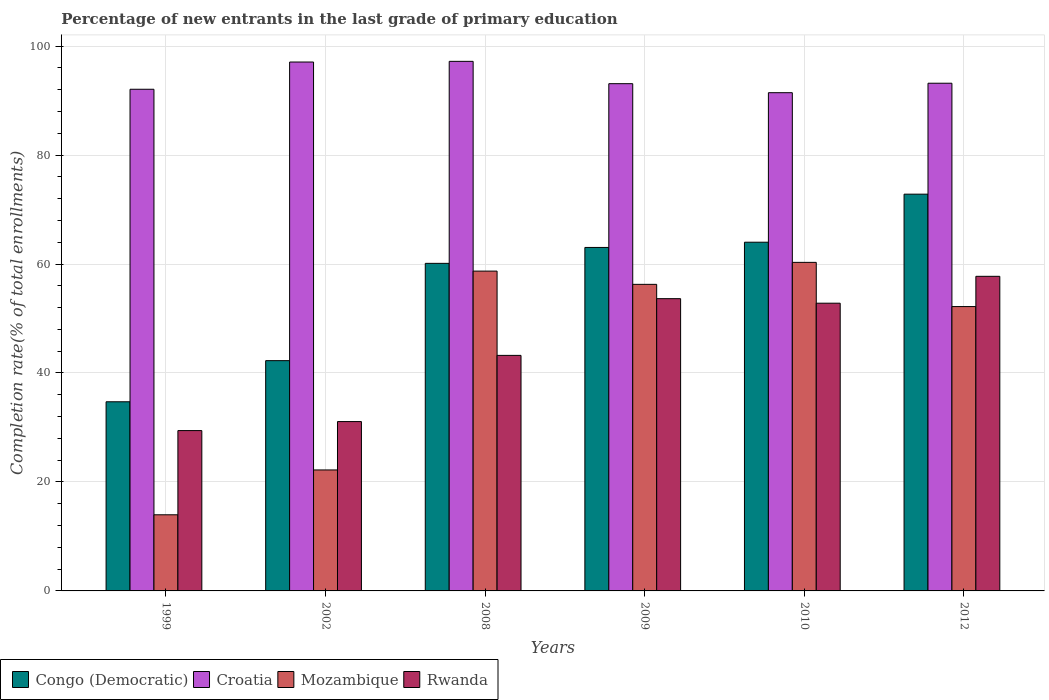How many groups of bars are there?
Offer a terse response. 6. Are the number of bars per tick equal to the number of legend labels?
Make the answer very short. Yes. How many bars are there on the 6th tick from the left?
Give a very brief answer. 4. How many bars are there on the 1st tick from the right?
Your answer should be very brief. 4. What is the percentage of new entrants in Rwanda in 2002?
Give a very brief answer. 31.08. Across all years, what is the maximum percentage of new entrants in Rwanda?
Your answer should be very brief. 57.74. Across all years, what is the minimum percentage of new entrants in Rwanda?
Your answer should be very brief. 29.43. What is the total percentage of new entrants in Mozambique in the graph?
Your answer should be very brief. 263.62. What is the difference between the percentage of new entrants in Congo (Democratic) in 1999 and that in 2002?
Give a very brief answer. -7.55. What is the difference between the percentage of new entrants in Mozambique in 2002 and the percentage of new entrants in Croatia in 1999?
Your answer should be very brief. -69.87. What is the average percentage of new entrants in Mozambique per year?
Provide a succinct answer. 43.94. In the year 2009, what is the difference between the percentage of new entrants in Mozambique and percentage of new entrants in Croatia?
Make the answer very short. -36.83. In how many years, is the percentage of new entrants in Rwanda greater than 28 %?
Your answer should be very brief. 6. What is the ratio of the percentage of new entrants in Rwanda in 1999 to that in 2002?
Your response must be concise. 0.95. Is the percentage of new entrants in Rwanda in 2009 less than that in 2010?
Give a very brief answer. No. Is the difference between the percentage of new entrants in Mozambique in 2009 and 2012 greater than the difference between the percentage of new entrants in Croatia in 2009 and 2012?
Make the answer very short. Yes. What is the difference between the highest and the second highest percentage of new entrants in Rwanda?
Provide a short and direct response. 4.1. What is the difference between the highest and the lowest percentage of new entrants in Rwanda?
Give a very brief answer. 28.31. Is the sum of the percentage of new entrants in Rwanda in 2002 and 2010 greater than the maximum percentage of new entrants in Mozambique across all years?
Offer a very short reply. Yes. What does the 1st bar from the left in 2008 represents?
Your answer should be very brief. Congo (Democratic). What does the 3rd bar from the right in 2008 represents?
Your answer should be compact. Croatia. How many bars are there?
Give a very brief answer. 24. Are all the bars in the graph horizontal?
Keep it short and to the point. No. What is the difference between two consecutive major ticks on the Y-axis?
Make the answer very short. 20. Are the values on the major ticks of Y-axis written in scientific E-notation?
Offer a terse response. No. What is the title of the graph?
Give a very brief answer. Percentage of new entrants in the last grade of primary education. What is the label or title of the X-axis?
Offer a very short reply. Years. What is the label or title of the Y-axis?
Your response must be concise. Completion rate(% of total enrollments). What is the Completion rate(% of total enrollments) of Congo (Democratic) in 1999?
Your answer should be compact. 34.71. What is the Completion rate(% of total enrollments) of Croatia in 1999?
Your answer should be compact. 92.07. What is the Completion rate(% of total enrollments) in Mozambique in 1999?
Give a very brief answer. 13.97. What is the Completion rate(% of total enrollments) of Rwanda in 1999?
Keep it short and to the point. 29.43. What is the Completion rate(% of total enrollments) in Congo (Democratic) in 2002?
Ensure brevity in your answer.  42.26. What is the Completion rate(% of total enrollments) of Croatia in 2002?
Offer a very short reply. 97.07. What is the Completion rate(% of total enrollments) of Mozambique in 2002?
Give a very brief answer. 22.2. What is the Completion rate(% of total enrollments) in Rwanda in 2002?
Your answer should be compact. 31.08. What is the Completion rate(% of total enrollments) in Congo (Democratic) in 2008?
Make the answer very short. 60.12. What is the Completion rate(% of total enrollments) of Croatia in 2008?
Provide a succinct answer. 97.19. What is the Completion rate(% of total enrollments) of Mozambique in 2008?
Make the answer very short. 58.7. What is the Completion rate(% of total enrollments) in Rwanda in 2008?
Ensure brevity in your answer.  43.23. What is the Completion rate(% of total enrollments) in Congo (Democratic) in 2009?
Keep it short and to the point. 63.04. What is the Completion rate(% of total enrollments) of Croatia in 2009?
Give a very brief answer. 93.09. What is the Completion rate(% of total enrollments) of Mozambique in 2009?
Provide a succinct answer. 56.26. What is the Completion rate(% of total enrollments) in Rwanda in 2009?
Your answer should be very brief. 53.64. What is the Completion rate(% of total enrollments) of Congo (Democratic) in 2010?
Offer a very short reply. 64. What is the Completion rate(% of total enrollments) in Croatia in 2010?
Your response must be concise. 91.44. What is the Completion rate(% of total enrollments) of Mozambique in 2010?
Give a very brief answer. 60.3. What is the Completion rate(% of total enrollments) of Rwanda in 2010?
Your answer should be very brief. 52.81. What is the Completion rate(% of total enrollments) in Congo (Democratic) in 2012?
Keep it short and to the point. 72.82. What is the Completion rate(% of total enrollments) of Croatia in 2012?
Provide a short and direct response. 93.18. What is the Completion rate(% of total enrollments) of Mozambique in 2012?
Make the answer very short. 52.19. What is the Completion rate(% of total enrollments) of Rwanda in 2012?
Provide a short and direct response. 57.74. Across all years, what is the maximum Completion rate(% of total enrollments) of Congo (Democratic)?
Provide a short and direct response. 72.82. Across all years, what is the maximum Completion rate(% of total enrollments) of Croatia?
Offer a terse response. 97.19. Across all years, what is the maximum Completion rate(% of total enrollments) in Mozambique?
Give a very brief answer. 60.3. Across all years, what is the maximum Completion rate(% of total enrollments) of Rwanda?
Provide a short and direct response. 57.74. Across all years, what is the minimum Completion rate(% of total enrollments) of Congo (Democratic)?
Ensure brevity in your answer.  34.71. Across all years, what is the minimum Completion rate(% of total enrollments) of Croatia?
Provide a succinct answer. 91.44. Across all years, what is the minimum Completion rate(% of total enrollments) in Mozambique?
Offer a terse response. 13.97. Across all years, what is the minimum Completion rate(% of total enrollments) in Rwanda?
Provide a short and direct response. 29.43. What is the total Completion rate(% of total enrollments) of Congo (Democratic) in the graph?
Make the answer very short. 336.95. What is the total Completion rate(% of total enrollments) in Croatia in the graph?
Your response must be concise. 564.04. What is the total Completion rate(% of total enrollments) in Mozambique in the graph?
Your answer should be very brief. 263.62. What is the total Completion rate(% of total enrollments) of Rwanda in the graph?
Your answer should be very brief. 267.92. What is the difference between the Completion rate(% of total enrollments) in Congo (Democratic) in 1999 and that in 2002?
Give a very brief answer. -7.55. What is the difference between the Completion rate(% of total enrollments) of Croatia in 1999 and that in 2002?
Offer a terse response. -5. What is the difference between the Completion rate(% of total enrollments) of Mozambique in 1999 and that in 2002?
Provide a succinct answer. -8.23. What is the difference between the Completion rate(% of total enrollments) in Rwanda in 1999 and that in 2002?
Your answer should be very brief. -1.66. What is the difference between the Completion rate(% of total enrollments) in Congo (Democratic) in 1999 and that in 2008?
Provide a short and direct response. -25.4. What is the difference between the Completion rate(% of total enrollments) of Croatia in 1999 and that in 2008?
Offer a terse response. -5.12. What is the difference between the Completion rate(% of total enrollments) of Mozambique in 1999 and that in 2008?
Your answer should be very brief. -44.72. What is the difference between the Completion rate(% of total enrollments) in Rwanda in 1999 and that in 2008?
Your answer should be very brief. -13.8. What is the difference between the Completion rate(% of total enrollments) in Congo (Democratic) in 1999 and that in 2009?
Your answer should be compact. -28.33. What is the difference between the Completion rate(% of total enrollments) in Croatia in 1999 and that in 2009?
Your answer should be very brief. -1.02. What is the difference between the Completion rate(% of total enrollments) in Mozambique in 1999 and that in 2009?
Your answer should be very brief. -42.29. What is the difference between the Completion rate(% of total enrollments) in Rwanda in 1999 and that in 2009?
Your answer should be very brief. -24.21. What is the difference between the Completion rate(% of total enrollments) of Congo (Democratic) in 1999 and that in 2010?
Your answer should be very brief. -29.28. What is the difference between the Completion rate(% of total enrollments) of Croatia in 1999 and that in 2010?
Offer a very short reply. 0.63. What is the difference between the Completion rate(% of total enrollments) of Mozambique in 1999 and that in 2010?
Make the answer very short. -46.33. What is the difference between the Completion rate(% of total enrollments) in Rwanda in 1999 and that in 2010?
Provide a short and direct response. -23.38. What is the difference between the Completion rate(% of total enrollments) in Congo (Democratic) in 1999 and that in 2012?
Provide a succinct answer. -38.1. What is the difference between the Completion rate(% of total enrollments) in Croatia in 1999 and that in 2012?
Ensure brevity in your answer.  -1.11. What is the difference between the Completion rate(% of total enrollments) of Mozambique in 1999 and that in 2012?
Your answer should be very brief. -38.21. What is the difference between the Completion rate(% of total enrollments) of Rwanda in 1999 and that in 2012?
Keep it short and to the point. -28.31. What is the difference between the Completion rate(% of total enrollments) in Congo (Democratic) in 2002 and that in 2008?
Provide a short and direct response. -17.86. What is the difference between the Completion rate(% of total enrollments) in Croatia in 2002 and that in 2008?
Your answer should be very brief. -0.12. What is the difference between the Completion rate(% of total enrollments) of Mozambique in 2002 and that in 2008?
Provide a short and direct response. -36.49. What is the difference between the Completion rate(% of total enrollments) of Rwanda in 2002 and that in 2008?
Offer a terse response. -12.15. What is the difference between the Completion rate(% of total enrollments) of Congo (Democratic) in 2002 and that in 2009?
Make the answer very short. -20.78. What is the difference between the Completion rate(% of total enrollments) of Croatia in 2002 and that in 2009?
Provide a short and direct response. 3.97. What is the difference between the Completion rate(% of total enrollments) in Mozambique in 2002 and that in 2009?
Give a very brief answer. -34.06. What is the difference between the Completion rate(% of total enrollments) of Rwanda in 2002 and that in 2009?
Your answer should be very brief. -22.56. What is the difference between the Completion rate(% of total enrollments) of Congo (Democratic) in 2002 and that in 2010?
Ensure brevity in your answer.  -21.74. What is the difference between the Completion rate(% of total enrollments) of Croatia in 2002 and that in 2010?
Provide a succinct answer. 5.63. What is the difference between the Completion rate(% of total enrollments) of Mozambique in 2002 and that in 2010?
Provide a short and direct response. -38.1. What is the difference between the Completion rate(% of total enrollments) of Rwanda in 2002 and that in 2010?
Your answer should be very brief. -21.72. What is the difference between the Completion rate(% of total enrollments) in Congo (Democratic) in 2002 and that in 2012?
Give a very brief answer. -30.56. What is the difference between the Completion rate(% of total enrollments) of Croatia in 2002 and that in 2012?
Your response must be concise. 3.89. What is the difference between the Completion rate(% of total enrollments) of Mozambique in 2002 and that in 2012?
Your response must be concise. -29.98. What is the difference between the Completion rate(% of total enrollments) of Rwanda in 2002 and that in 2012?
Keep it short and to the point. -26.66. What is the difference between the Completion rate(% of total enrollments) in Congo (Democratic) in 2008 and that in 2009?
Offer a terse response. -2.92. What is the difference between the Completion rate(% of total enrollments) of Croatia in 2008 and that in 2009?
Give a very brief answer. 4.1. What is the difference between the Completion rate(% of total enrollments) in Mozambique in 2008 and that in 2009?
Your answer should be compact. 2.43. What is the difference between the Completion rate(% of total enrollments) of Rwanda in 2008 and that in 2009?
Make the answer very short. -10.41. What is the difference between the Completion rate(% of total enrollments) in Congo (Democratic) in 2008 and that in 2010?
Provide a short and direct response. -3.88. What is the difference between the Completion rate(% of total enrollments) in Croatia in 2008 and that in 2010?
Your answer should be compact. 5.75. What is the difference between the Completion rate(% of total enrollments) in Mozambique in 2008 and that in 2010?
Offer a very short reply. -1.6. What is the difference between the Completion rate(% of total enrollments) of Rwanda in 2008 and that in 2010?
Offer a very short reply. -9.58. What is the difference between the Completion rate(% of total enrollments) in Congo (Democratic) in 2008 and that in 2012?
Keep it short and to the point. -12.7. What is the difference between the Completion rate(% of total enrollments) of Croatia in 2008 and that in 2012?
Your answer should be very brief. 4.01. What is the difference between the Completion rate(% of total enrollments) in Mozambique in 2008 and that in 2012?
Offer a terse response. 6.51. What is the difference between the Completion rate(% of total enrollments) in Rwanda in 2008 and that in 2012?
Provide a succinct answer. -14.51. What is the difference between the Completion rate(% of total enrollments) in Congo (Democratic) in 2009 and that in 2010?
Give a very brief answer. -0.96. What is the difference between the Completion rate(% of total enrollments) in Croatia in 2009 and that in 2010?
Make the answer very short. 1.65. What is the difference between the Completion rate(% of total enrollments) in Mozambique in 2009 and that in 2010?
Your answer should be compact. -4.04. What is the difference between the Completion rate(% of total enrollments) of Rwanda in 2009 and that in 2010?
Give a very brief answer. 0.83. What is the difference between the Completion rate(% of total enrollments) of Congo (Democratic) in 2009 and that in 2012?
Offer a very short reply. -9.78. What is the difference between the Completion rate(% of total enrollments) of Croatia in 2009 and that in 2012?
Your response must be concise. -0.08. What is the difference between the Completion rate(% of total enrollments) of Mozambique in 2009 and that in 2012?
Offer a very short reply. 4.08. What is the difference between the Completion rate(% of total enrollments) in Rwanda in 2009 and that in 2012?
Keep it short and to the point. -4.1. What is the difference between the Completion rate(% of total enrollments) of Congo (Democratic) in 2010 and that in 2012?
Give a very brief answer. -8.82. What is the difference between the Completion rate(% of total enrollments) of Croatia in 2010 and that in 2012?
Offer a terse response. -1.74. What is the difference between the Completion rate(% of total enrollments) in Mozambique in 2010 and that in 2012?
Ensure brevity in your answer.  8.11. What is the difference between the Completion rate(% of total enrollments) of Rwanda in 2010 and that in 2012?
Your answer should be compact. -4.93. What is the difference between the Completion rate(% of total enrollments) in Congo (Democratic) in 1999 and the Completion rate(% of total enrollments) in Croatia in 2002?
Provide a succinct answer. -62.35. What is the difference between the Completion rate(% of total enrollments) of Congo (Democratic) in 1999 and the Completion rate(% of total enrollments) of Mozambique in 2002?
Provide a short and direct response. 12.51. What is the difference between the Completion rate(% of total enrollments) in Congo (Democratic) in 1999 and the Completion rate(% of total enrollments) in Rwanda in 2002?
Your answer should be compact. 3.63. What is the difference between the Completion rate(% of total enrollments) of Croatia in 1999 and the Completion rate(% of total enrollments) of Mozambique in 2002?
Your answer should be compact. 69.87. What is the difference between the Completion rate(% of total enrollments) of Croatia in 1999 and the Completion rate(% of total enrollments) of Rwanda in 2002?
Your answer should be compact. 60.99. What is the difference between the Completion rate(% of total enrollments) in Mozambique in 1999 and the Completion rate(% of total enrollments) in Rwanda in 2002?
Your answer should be compact. -17.11. What is the difference between the Completion rate(% of total enrollments) in Congo (Democratic) in 1999 and the Completion rate(% of total enrollments) in Croatia in 2008?
Offer a very short reply. -62.48. What is the difference between the Completion rate(% of total enrollments) in Congo (Democratic) in 1999 and the Completion rate(% of total enrollments) in Mozambique in 2008?
Offer a very short reply. -23.98. What is the difference between the Completion rate(% of total enrollments) of Congo (Democratic) in 1999 and the Completion rate(% of total enrollments) of Rwanda in 2008?
Your response must be concise. -8.52. What is the difference between the Completion rate(% of total enrollments) of Croatia in 1999 and the Completion rate(% of total enrollments) of Mozambique in 2008?
Your answer should be compact. 33.38. What is the difference between the Completion rate(% of total enrollments) in Croatia in 1999 and the Completion rate(% of total enrollments) in Rwanda in 2008?
Keep it short and to the point. 48.84. What is the difference between the Completion rate(% of total enrollments) of Mozambique in 1999 and the Completion rate(% of total enrollments) of Rwanda in 2008?
Your response must be concise. -29.26. What is the difference between the Completion rate(% of total enrollments) in Congo (Democratic) in 1999 and the Completion rate(% of total enrollments) in Croatia in 2009?
Your answer should be compact. -58.38. What is the difference between the Completion rate(% of total enrollments) in Congo (Democratic) in 1999 and the Completion rate(% of total enrollments) in Mozambique in 2009?
Your answer should be compact. -21.55. What is the difference between the Completion rate(% of total enrollments) in Congo (Democratic) in 1999 and the Completion rate(% of total enrollments) in Rwanda in 2009?
Offer a terse response. -18.93. What is the difference between the Completion rate(% of total enrollments) of Croatia in 1999 and the Completion rate(% of total enrollments) of Mozambique in 2009?
Provide a succinct answer. 35.81. What is the difference between the Completion rate(% of total enrollments) in Croatia in 1999 and the Completion rate(% of total enrollments) in Rwanda in 2009?
Provide a short and direct response. 38.43. What is the difference between the Completion rate(% of total enrollments) of Mozambique in 1999 and the Completion rate(% of total enrollments) of Rwanda in 2009?
Your response must be concise. -39.67. What is the difference between the Completion rate(% of total enrollments) in Congo (Democratic) in 1999 and the Completion rate(% of total enrollments) in Croatia in 2010?
Provide a short and direct response. -56.73. What is the difference between the Completion rate(% of total enrollments) of Congo (Democratic) in 1999 and the Completion rate(% of total enrollments) of Mozambique in 2010?
Offer a terse response. -25.59. What is the difference between the Completion rate(% of total enrollments) of Congo (Democratic) in 1999 and the Completion rate(% of total enrollments) of Rwanda in 2010?
Make the answer very short. -18.09. What is the difference between the Completion rate(% of total enrollments) of Croatia in 1999 and the Completion rate(% of total enrollments) of Mozambique in 2010?
Keep it short and to the point. 31.77. What is the difference between the Completion rate(% of total enrollments) of Croatia in 1999 and the Completion rate(% of total enrollments) of Rwanda in 2010?
Make the answer very short. 39.26. What is the difference between the Completion rate(% of total enrollments) of Mozambique in 1999 and the Completion rate(% of total enrollments) of Rwanda in 2010?
Provide a short and direct response. -38.83. What is the difference between the Completion rate(% of total enrollments) of Congo (Democratic) in 1999 and the Completion rate(% of total enrollments) of Croatia in 2012?
Your answer should be compact. -58.46. What is the difference between the Completion rate(% of total enrollments) of Congo (Democratic) in 1999 and the Completion rate(% of total enrollments) of Mozambique in 2012?
Offer a very short reply. -17.47. What is the difference between the Completion rate(% of total enrollments) in Congo (Democratic) in 1999 and the Completion rate(% of total enrollments) in Rwanda in 2012?
Your answer should be very brief. -23.03. What is the difference between the Completion rate(% of total enrollments) of Croatia in 1999 and the Completion rate(% of total enrollments) of Mozambique in 2012?
Give a very brief answer. 39.89. What is the difference between the Completion rate(% of total enrollments) in Croatia in 1999 and the Completion rate(% of total enrollments) in Rwanda in 2012?
Provide a succinct answer. 34.33. What is the difference between the Completion rate(% of total enrollments) in Mozambique in 1999 and the Completion rate(% of total enrollments) in Rwanda in 2012?
Give a very brief answer. -43.77. What is the difference between the Completion rate(% of total enrollments) of Congo (Democratic) in 2002 and the Completion rate(% of total enrollments) of Croatia in 2008?
Your answer should be very brief. -54.93. What is the difference between the Completion rate(% of total enrollments) in Congo (Democratic) in 2002 and the Completion rate(% of total enrollments) in Mozambique in 2008?
Keep it short and to the point. -16.43. What is the difference between the Completion rate(% of total enrollments) of Congo (Democratic) in 2002 and the Completion rate(% of total enrollments) of Rwanda in 2008?
Your answer should be compact. -0.97. What is the difference between the Completion rate(% of total enrollments) in Croatia in 2002 and the Completion rate(% of total enrollments) in Mozambique in 2008?
Your response must be concise. 38.37. What is the difference between the Completion rate(% of total enrollments) of Croatia in 2002 and the Completion rate(% of total enrollments) of Rwanda in 2008?
Ensure brevity in your answer.  53.84. What is the difference between the Completion rate(% of total enrollments) of Mozambique in 2002 and the Completion rate(% of total enrollments) of Rwanda in 2008?
Keep it short and to the point. -21.02. What is the difference between the Completion rate(% of total enrollments) of Congo (Democratic) in 2002 and the Completion rate(% of total enrollments) of Croatia in 2009?
Offer a terse response. -50.83. What is the difference between the Completion rate(% of total enrollments) in Congo (Democratic) in 2002 and the Completion rate(% of total enrollments) in Mozambique in 2009?
Provide a short and direct response. -14. What is the difference between the Completion rate(% of total enrollments) of Congo (Democratic) in 2002 and the Completion rate(% of total enrollments) of Rwanda in 2009?
Give a very brief answer. -11.38. What is the difference between the Completion rate(% of total enrollments) in Croatia in 2002 and the Completion rate(% of total enrollments) in Mozambique in 2009?
Offer a terse response. 40.8. What is the difference between the Completion rate(% of total enrollments) of Croatia in 2002 and the Completion rate(% of total enrollments) of Rwanda in 2009?
Your answer should be very brief. 43.43. What is the difference between the Completion rate(% of total enrollments) of Mozambique in 2002 and the Completion rate(% of total enrollments) of Rwanda in 2009?
Your answer should be very brief. -31.43. What is the difference between the Completion rate(% of total enrollments) of Congo (Democratic) in 2002 and the Completion rate(% of total enrollments) of Croatia in 2010?
Make the answer very short. -49.18. What is the difference between the Completion rate(% of total enrollments) in Congo (Democratic) in 2002 and the Completion rate(% of total enrollments) in Mozambique in 2010?
Provide a succinct answer. -18.04. What is the difference between the Completion rate(% of total enrollments) of Congo (Democratic) in 2002 and the Completion rate(% of total enrollments) of Rwanda in 2010?
Keep it short and to the point. -10.55. What is the difference between the Completion rate(% of total enrollments) of Croatia in 2002 and the Completion rate(% of total enrollments) of Mozambique in 2010?
Offer a terse response. 36.77. What is the difference between the Completion rate(% of total enrollments) in Croatia in 2002 and the Completion rate(% of total enrollments) in Rwanda in 2010?
Make the answer very short. 44.26. What is the difference between the Completion rate(% of total enrollments) of Mozambique in 2002 and the Completion rate(% of total enrollments) of Rwanda in 2010?
Offer a very short reply. -30.6. What is the difference between the Completion rate(% of total enrollments) of Congo (Democratic) in 2002 and the Completion rate(% of total enrollments) of Croatia in 2012?
Your answer should be very brief. -50.92. What is the difference between the Completion rate(% of total enrollments) of Congo (Democratic) in 2002 and the Completion rate(% of total enrollments) of Mozambique in 2012?
Ensure brevity in your answer.  -9.92. What is the difference between the Completion rate(% of total enrollments) in Congo (Democratic) in 2002 and the Completion rate(% of total enrollments) in Rwanda in 2012?
Your answer should be very brief. -15.48. What is the difference between the Completion rate(% of total enrollments) of Croatia in 2002 and the Completion rate(% of total enrollments) of Mozambique in 2012?
Make the answer very short. 44.88. What is the difference between the Completion rate(% of total enrollments) in Croatia in 2002 and the Completion rate(% of total enrollments) in Rwanda in 2012?
Provide a short and direct response. 39.33. What is the difference between the Completion rate(% of total enrollments) in Mozambique in 2002 and the Completion rate(% of total enrollments) in Rwanda in 2012?
Provide a short and direct response. -35.54. What is the difference between the Completion rate(% of total enrollments) of Congo (Democratic) in 2008 and the Completion rate(% of total enrollments) of Croatia in 2009?
Provide a succinct answer. -32.98. What is the difference between the Completion rate(% of total enrollments) of Congo (Democratic) in 2008 and the Completion rate(% of total enrollments) of Mozambique in 2009?
Offer a terse response. 3.85. What is the difference between the Completion rate(% of total enrollments) in Congo (Democratic) in 2008 and the Completion rate(% of total enrollments) in Rwanda in 2009?
Offer a very short reply. 6.48. What is the difference between the Completion rate(% of total enrollments) of Croatia in 2008 and the Completion rate(% of total enrollments) of Mozambique in 2009?
Offer a very short reply. 40.93. What is the difference between the Completion rate(% of total enrollments) in Croatia in 2008 and the Completion rate(% of total enrollments) in Rwanda in 2009?
Make the answer very short. 43.55. What is the difference between the Completion rate(% of total enrollments) of Mozambique in 2008 and the Completion rate(% of total enrollments) of Rwanda in 2009?
Keep it short and to the point. 5.06. What is the difference between the Completion rate(% of total enrollments) of Congo (Democratic) in 2008 and the Completion rate(% of total enrollments) of Croatia in 2010?
Give a very brief answer. -31.32. What is the difference between the Completion rate(% of total enrollments) in Congo (Democratic) in 2008 and the Completion rate(% of total enrollments) in Mozambique in 2010?
Provide a succinct answer. -0.18. What is the difference between the Completion rate(% of total enrollments) of Congo (Democratic) in 2008 and the Completion rate(% of total enrollments) of Rwanda in 2010?
Your answer should be compact. 7.31. What is the difference between the Completion rate(% of total enrollments) of Croatia in 2008 and the Completion rate(% of total enrollments) of Mozambique in 2010?
Provide a succinct answer. 36.89. What is the difference between the Completion rate(% of total enrollments) of Croatia in 2008 and the Completion rate(% of total enrollments) of Rwanda in 2010?
Your answer should be compact. 44.38. What is the difference between the Completion rate(% of total enrollments) of Mozambique in 2008 and the Completion rate(% of total enrollments) of Rwanda in 2010?
Ensure brevity in your answer.  5.89. What is the difference between the Completion rate(% of total enrollments) of Congo (Democratic) in 2008 and the Completion rate(% of total enrollments) of Croatia in 2012?
Provide a short and direct response. -33.06. What is the difference between the Completion rate(% of total enrollments) of Congo (Democratic) in 2008 and the Completion rate(% of total enrollments) of Mozambique in 2012?
Keep it short and to the point. 7.93. What is the difference between the Completion rate(% of total enrollments) in Congo (Democratic) in 2008 and the Completion rate(% of total enrollments) in Rwanda in 2012?
Make the answer very short. 2.38. What is the difference between the Completion rate(% of total enrollments) in Croatia in 2008 and the Completion rate(% of total enrollments) in Mozambique in 2012?
Make the answer very short. 45.01. What is the difference between the Completion rate(% of total enrollments) in Croatia in 2008 and the Completion rate(% of total enrollments) in Rwanda in 2012?
Keep it short and to the point. 39.45. What is the difference between the Completion rate(% of total enrollments) in Mozambique in 2008 and the Completion rate(% of total enrollments) in Rwanda in 2012?
Provide a succinct answer. 0.96. What is the difference between the Completion rate(% of total enrollments) of Congo (Democratic) in 2009 and the Completion rate(% of total enrollments) of Croatia in 2010?
Offer a very short reply. -28.4. What is the difference between the Completion rate(% of total enrollments) of Congo (Democratic) in 2009 and the Completion rate(% of total enrollments) of Mozambique in 2010?
Make the answer very short. 2.74. What is the difference between the Completion rate(% of total enrollments) in Congo (Democratic) in 2009 and the Completion rate(% of total enrollments) in Rwanda in 2010?
Give a very brief answer. 10.23. What is the difference between the Completion rate(% of total enrollments) in Croatia in 2009 and the Completion rate(% of total enrollments) in Mozambique in 2010?
Offer a very short reply. 32.79. What is the difference between the Completion rate(% of total enrollments) in Croatia in 2009 and the Completion rate(% of total enrollments) in Rwanda in 2010?
Offer a very short reply. 40.29. What is the difference between the Completion rate(% of total enrollments) of Mozambique in 2009 and the Completion rate(% of total enrollments) of Rwanda in 2010?
Provide a short and direct response. 3.46. What is the difference between the Completion rate(% of total enrollments) of Congo (Democratic) in 2009 and the Completion rate(% of total enrollments) of Croatia in 2012?
Make the answer very short. -30.14. What is the difference between the Completion rate(% of total enrollments) of Congo (Democratic) in 2009 and the Completion rate(% of total enrollments) of Mozambique in 2012?
Offer a terse response. 10.85. What is the difference between the Completion rate(% of total enrollments) of Congo (Democratic) in 2009 and the Completion rate(% of total enrollments) of Rwanda in 2012?
Keep it short and to the point. 5.3. What is the difference between the Completion rate(% of total enrollments) in Croatia in 2009 and the Completion rate(% of total enrollments) in Mozambique in 2012?
Ensure brevity in your answer.  40.91. What is the difference between the Completion rate(% of total enrollments) in Croatia in 2009 and the Completion rate(% of total enrollments) in Rwanda in 2012?
Make the answer very short. 35.35. What is the difference between the Completion rate(% of total enrollments) of Mozambique in 2009 and the Completion rate(% of total enrollments) of Rwanda in 2012?
Your response must be concise. -1.48. What is the difference between the Completion rate(% of total enrollments) of Congo (Democratic) in 2010 and the Completion rate(% of total enrollments) of Croatia in 2012?
Ensure brevity in your answer.  -29.18. What is the difference between the Completion rate(% of total enrollments) of Congo (Democratic) in 2010 and the Completion rate(% of total enrollments) of Mozambique in 2012?
Ensure brevity in your answer.  11.81. What is the difference between the Completion rate(% of total enrollments) of Congo (Democratic) in 2010 and the Completion rate(% of total enrollments) of Rwanda in 2012?
Provide a short and direct response. 6.26. What is the difference between the Completion rate(% of total enrollments) of Croatia in 2010 and the Completion rate(% of total enrollments) of Mozambique in 2012?
Provide a succinct answer. 39.25. What is the difference between the Completion rate(% of total enrollments) in Croatia in 2010 and the Completion rate(% of total enrollments) in Rwanda in 2012?
Offer a very short reply. 33.7. What is the difference between the Completion rate(% of total enrollments) of Mozambique in 2010 and the Completion rate(% of total enrollments) of Rwanda in 2012?
Your answer should be very brief. 2.56. What is the average Completion rate(% of total enrollments) of Congo (Democratic) per year?
Keep it short and to the point. 56.16. What is the average Completion rate(% of total enrollments) in Croatia per year?
Offer a very short reply. 94.01. What is the average Completion rate(% of total enrollments) in Mozambique per year?
Provide a short and direct response. 43.94. What is the average Completion rate(% of total enrollments) in Rwanda per year?
Provide a short and direct response. 44.65. In the year 1999, what is the difference between the Completion rate(% of total enrollments) in Congo (Democratic) and Completion rate(% of total enrollments) in Croatia?
Keep it short and to the point. -57.36. In the year 1999, what is the difference between the Completion rate(% of total enrollments) of Congo (Democratic) and Completion rate(% of total enrollments) of Mozambique?
Your answer should be very brief. 20.74. In the year 1999, what is the difference between the Completion rate(% of total enrollments) of Congo (Democratic) and Completion rate(% of total enrollments) of Rwanda?
Give a very brief answer. 5.29. In the year 1999, what is the difference between the Completion rate(% of total enrollments) of Croatia and Completion rate(% of total enrollments) of Mozambique?
Your response must be concise. 78.1. In the year 1999, what is the difference between the Completion rate(% of total enrollments) of Croatia and Completion rate(% of total enrollments) of Rwanda?
Provide a succinct answer. 62.65. In the year 1999, what is the difference between the Completion rate(% of total enrollments) in Mozambique and Completion rate(% of total enrollments) in Rwanda?
Ensure brevity in your answer.  -15.45. In the year 2002, what is the difference between the Completion rate(% of total enrollments) in Congo (Democratic) and Completion rate(% of total enrollments) in Croatia?
Offer a terse response. -54.81. In the year 2002, what is the difference between the Completion rate(% of total enrollments) in Congo (Democratic) and Completion rate(% of total enrollments) in Mozambique?
Offer a very short reply. 20.06. In the year 2002, what is the difference between the Completion rate(% of total enrollments) of Congo (Democratic) and Completion rate(% of total enrollments) of Rwanda?
Your answer should be compact. 11.18. In the year 2002, what is the difference between the Completion rate(% of total enrollments) in Croatia and Completion rate(% of total enrollments) in Mozambique?
Provide a succinct answer. 74.86. In the year 2002, what is the difference between the Completion rate(% of total enrollments) of Croatia and Completion rate(% of total enrollments) of Rwanda?
Provide a succinct answer. 65.99. In the year 2002, what is the difference between the Completion rate(% of total enrollments) in Mozambique and Completion rate(% of total enrollments) in Rwanda?
Your answer should be very brief. -8.88. In the year 2008, what is the difference between the Completion rate(% of total enrollments) of Congo (Democratic) and Completion rate(% of total enrollments) of Croatia?
Your answer should be very brief. -37.07. In the year 2008, what is the difference between the Completion rate(% of total enrollments) in Congo (Democratic) and Completion rate(% of total enrollments) in Mozambique?
Offer a very short reply. 1.42. In the year 2008, what is the difference between the Completion rate(% of total enrollments) of Congo (Democratic) and Completion rate(% of total enrollments) of Rwanda?
Your answer should be compact. 16.89. In the year 2008, what is the difference between the Completion rate(% of total enrollments) of Croatia and Completion rate(% of total enrollments) of Mozambique?
Keep it short and to the point. 38.5. In the year 2008, what is the difference between the Completion rate(% of total enrollments) of Croatia and Completion rate(% of total enrollments) of Rwanda?
Make the answer very short. 53.96. In the year 2008, what is the difference between the Completion rate(% of total enrollments) in Mozambique and Completion rate(% of total enrollments) in Rwanda?
Make the answer very short. 15.47. In the year 2009, what is the difference between the Completion rate(% of total enrollments) in Congo (Democratic) and Completion rate(% of total enrollments) in Croatia?
Ensure brevity in your answer.  -30.05. In the year 2009, what is the difference between the Completion rate(% of total enrollments) in Congo (Democratic) and Completion rate(% of total enrollments) in Mozambique?
Your response must be concise. 6.78. In the year 2009, what is the difference between the Completion rate(% of total enrollments) in Congo (Democratic) and Completion rate(% of total enrollments) in Rwanda?
Keep it short and to the point. 9.4. In the year 2009, what is the difference between the Completion rate(% of total enrollments) in Croatia and Completion rate(% of total enrollments) in Mozambique?
Offer a very short reply. 36.83. In the year 2009, what is the difference between the Completion rate(% of total enrollments) of Croatia and Completion rate(% of total enrollments) of Rwanda?
Offer a terse response. 39.45. In the year 2009, what is the difference between the Completion rate(% of total enrollments) of Mozambique and Completion rate(% of total enrollments) of Rwanda?
Ensure brevity in your answer.  2.62. In the year 2010, what is the difference between the Completion rate(% of total enrollments) in Congo (Democratic) and Completion rate(% of total enrollments) in Croatia?
Your response must be concise. -27.44. In the year 2010, what is the difference between the Completion rate(% of total enrollments) of Congo (Democratic) and Completion rate(% of total enrollments) of Mozambique?
Ensure brevity in your answer.  3.7. In the year 2010, what is the difference between the Completion rate(% of total enrollments) in Congo (Democratic) and Completion rate(% of total enrollments) in Rwanda?
Your answer should be very brief. 11.19. In the year 2010, what is the difference between the Completion rate(% of total enrollments) of Croatia and Completion rate(% of total enrollments) of Mozambique?
Offer a very short reply. 31.14. In the year 2010, what is the difference between the Completion rate(% of total enrollments) of Croatia and Completion rate(% of total enrollments) of Rwanda?
Your response must be concise. 38.63. In the year 2010, what is the difference between the Completion rate(% of total enrollments) in Mozambique and Completion rate(% of total enrollments) in Rwanda?
Your response must be concise. 7.49. In the year 2012, what is the difference between the Completion rate(% of total enrollments) of Congo (Democratic) and Completion rate(% of total enrollments) of Croatia?
Your answer should be compact. -20.36. In the year 2012, what is the difference between the Completion rate(% of total enrollments) of Congo (Democratic) and Completion rate(% of total enrollments) of Mozambique?
Your response must be concise. 20.63. In the year 2012, what is the difference between the Completion rate(% of total enrollments) of Congo (Democratic) and Completion rate(% of total enrollments) of Rwanda?
Ensure brevity in your answer.  15.08. In the year 2012, what is the difference between the Completion rate(% of total enrollments) in Croatia and Completion rate(% of total enrollments) in Mozambique?
Give a very brief answer. 40.99. In the year 2012, what is the difference between the Completion rate(% of total enrollments) of Croatia and Completion rate(% of total enrollments) of Rwanda?
Provide a succinct answer. 35.44. In the year 2012, what is the difference between the Completion rate(% of total enrollments) in Mozambique and Completion rate(% of total enrollments) in Rwanda?
Offer a very short reply. -5.55. What is the ratio of the Completion rate(% of total enrollments) in Congo (Democratic) in 1999 to that in 2002?
Offer a terse response. 0.82. What is the ratio of the Completion rate(% of total enrollments) of Croatia in 1999 to that in 2002?
Make the answer very short. 0.95. What is the ratio of the Completion rate(% of total enrollments) of Mozambique in 1999 to that in 2002?
Ensure brevity in your answer.  0.63. What is the ratio of the Completion rate(% of total enrollments) of Rwanda in 1999 to that in 2002?
Your response must be concise. 0.95. What is the ratio of the Completion rate(% of total enrollments) in Congo (Democratic) in 1999 to that in 2008?
Ensure brevity in your answer.  0.58. What is the ratio of the Completion rate(% of total enrollments) in Croatia in 1999 to that in 2008?
Your answer should be very brief. 0.95. What is the ratio of the Completion rate(% of total enrollments) of Mozambique in 1999 to that in 2008?
Ensure brevity in your answer.  0.24. What is the ratio of the Completion rate(% of total enrollments) of Rwanda in 1999 to that in 2008?
Ensure brevity in your answer.  0.68. What is the ratio of the Completion rate(% of total enrollments) in Congo (Democratic) in 1999 to that in 2009?
Offer a very short reply. 0.55. What is the ratio of the Completion rate(% of total enrollments) of Croatia in 1999 to that in 2009?
Offer a very short reply. 0.99. What is the ratio of the Completion rate(% of total enrollments) in Mozambique in 1999 to that in 2009?
Offer a terse response. 0.25. What is the ratio of the Completion rate(% of total enrollments) in Rwanda in 1999 to that in 2009?
Your answer should be compact. 0.55. What is the ratio of the Completion rate(% of total enrollments) of Congo (Democratic) in 1999 to that in 2010?
Make the answer very short. 0.54. What is the ratio of the Completion rate(% of total enrollments) of Croatia in 1999 to that in 2010?
Your response must be concise. 1.01. What is the ratio of the Completion rate(% of total enrollments) of Mozambique in 1999 to that in 2010?
Keep it short and to the point. 0.23. What is the ratio of the Completion rate(% of total enrollments) in Rwanda in 1999 to that in 2010?
Your answer should be very brief. 0.56. What is the ratio of the Completion rate(% of total enrollments) in Congo (Democratic) in 1999 to that in 2012?
Ensure brevity in your answer.  0.48. What is the ratio of the Completion rate(% of total enrollments) in Mozambique in 1999 to that in 2012?
Your answer should be very brief. 0.27. What is the ratio of the Completion rate(% of total enrollments) of Rwanda in 1999 to that in 2012?
Provide a succinct answer. 0.51. What is the ratio of the Completion rate(% of total enrollments) of Congo (Democratic) in 2002 to that in 2008?
Offer a terse response. 0.7. What is the ratio of the Completion rate(% of total enrollments) in Mozambique in 2002 to that in 2008?
Give a very brief answer. 0.38. What is the ratio of the Completion rate(% of total enrollments) of Rwanda in 2002 to that in 2008?
Your response must be concise. 0.72. What is the ratio of the Completion rate(% of total enrollments) in Congo (Democratic) in 2002 to that in 2009?
Your answer should be very brief. 0.67. What is the ratio of the Completion rate(% of total enrollments) of Croatia in 2002 to that in 2009?
Make the answer very short. 1.04. What is the ratio of the Completion rate(% of total enrollments) of Mozambique in 2002 to that in 2009?
Offer a terse response. 0.39. What is the ratio of the Completion rate(% of total enrollments) of Rwanda in 2002 to that in 2009?
Make the answer very short. 0.58. What is the ratio of the Completion rate(% of total enrollments) of Congo (Democratic) in 2002 to that in 2010?
Keep it short and to the point. 0.66. What is the ratio of the Completion rate(% of total enrollments) in Croatia in 2002 to that in 2010?
Keep it short and to the point. 1.06. What is the ratio of the Completion rate(% of total enrollments) in Mozambique in 2002 to that in 2010?
Make the answer very short. 0.37. What is the ratio of the Completion rate(% of total enrollments) of Rwanda in 2002 to that in 2010?
Provide a succinct answer. 0.59. What is the ratio of the Completion rate(% of total enrollments) in Congo (Democratic) in 2002 to that in 2012?
Provide a succinct answer. 0.58. What is the ratio of the Completion rate(% of total enrollments) of Croatia in 2002 to that in 2012?
Make the answer very short. 1.04. What is the ratio of the Completion rate(% of total enrollments) of Mozambique in 2002 to that in 2012?
Give a very brief answer. 0.43. What is the ratio of the Completion rate(% of total enrollments) in Rwanda in 2002 to that in 2012?
Give a very brief answer. 0.54. What is the ratio of the Completion rate(% of total enrollments) of Congo (Democratic) in 2008 to that in 2009?
Ensure brevity in your answer.  0.95. What is the ratio of the Completion rate(% of total enrollments) of Croatia in 2008 to that in 2009?
Keep it short and to the point. 1.04. What is the ratio of the Completion rate(% of total enrollments) in Mozambique in 2008 to that in 2009?
Your response must be concise. 1.04. What is the ratio of the Completion rate(% of total enrollments) in Rwanda in 2008 to that in 2009?
Give a very brief answer. 0.81. What is the ratio of the Completion rate(% of total enrollments) of Congo (Democratic) in 2008 to that in 2010?
Offer a very short reply. 0.94. What is the ratio of the Completion rate(% of total enrollments) of Croatia in 2008 to that in 2010?
Your answer should be very brief. 1.06. What is the ratio of the Completion rate(% of total enrollments) of Mozambique in 2008 to that in 2010?
Your answer should be very brief. 0.97. What is the ratio of the Completion rate(% of total enrollments) of Rwanda in 2008 to that in 2010?
Your answer should be compact. 0.82. What is the ratio of the Completion rate(% of total enrollments) of Congo (Democratic) in 2008 to that in 2012?
Provide a succinct answer. 0.83. What is the ratio of the Completion rate(% of total enrollments) of Croatia in 2008 to that in 2012?
Offer a very short reply. 1.04. What is the ratio of the Completion rate(% of total enrollments) of Mozambique in 2008 to that in 2012?
Your answer should be compact. 1.12. What is the ratio of the Completion rate(% of total enrollments) in Rwanda in 2008 to that in 2012?
Your answer should be very brief. 0.75. What is the ratio of the Completion rate(% of total enrollments) of Congo (Democratic) in 2009 to that in 2010?
Your answer should be compact. 0.98. What is the ratio of the Completion rate(% of total enrollments) of Croatia in 2009 to that in 2010?
Your answer should be very brief. 1.02. What is the ratio of the Completion rate(% of total enrollments) of Mozambique in 2009 to that in 2010?
Your response must be concise. 0.93. What is the ratio of the Completion rate(% of total enrollments) in Rwanda in 2009 to that in 2010?
Keep it short and to the point. 1.02. What is the ratio of the Completion rate(% of total enrollments) in Congo (Democratic) in 2009 to that in 2012?
Your response must be concise. 0.87. What is the ratio of the Completion rate(% of total enrollments) in Croatia in 2009 to that in 2012?
Give a very brief answer. 1. What is the ratio of the Completion rate(% of total enrollments) in Mozambique in 2009 to that in 2012?
Provide a short and direct response. 1.08. What is the ratio of the Completion rate(% of total enrollments) in Rwanda in 2009 to that in 2012?
Your answer should be compact. 0.93. What is the ratio of the Completion rate(% of total enrollments) of Congo (Democratic) in 2010 to that in 2012?
Your response must be concise. 0.88. What is the ratio of the Completion rate(% of total enrollments) of Croatia in 2010 to that in 2012?
Ensure brevity in your answer.  0.98. What is the ratio of the Completion rate(% of total enrollments) of Mozambique in 2010 to that in 2012?
Make the answer very short. 1.16. What is the ratio of the Completion rate(% of total enrollments) in Rwanda in 2010 to that in 2012?
Make the answer very short. 0.91. What is the difference between the highest and the second highest Completion rate(% of total enrollments) in Congo (Democratic)?
Your response must be concise. 8.82. What is the difference between the highest and the second highest Completion rate(% of total enrollments) in Croatia?
Make the answer very short. 0.12. What is the difference between the highest and the second highest Completion rate(% of total enrollments) in Mozambique?
Your answer should be very brief. 1.6. What is the difference between the highest and the second highest Completion rate(% of total enrollments) of Rwanda?
Offer a terse response. 4.1. What is the difference between the highest and the lowest Completion rate(% of total enrollments) in Congo (Democratic)?
Your answer should be very brief. 38.1. What is the difference between the highest and the lowest Completion rate(% of total enrollments) in Croatia?
Your answer should be compact. 5.75. What is the difference between the highest and the lowest Completion rate(% of total enrollments) of Mozambique?
Offer a very short reply. 46.33. What is the difference between the highest and the lowest Completion rate(% of total enrollments) in Rwanda?
Offer a terse response. 28.31. 